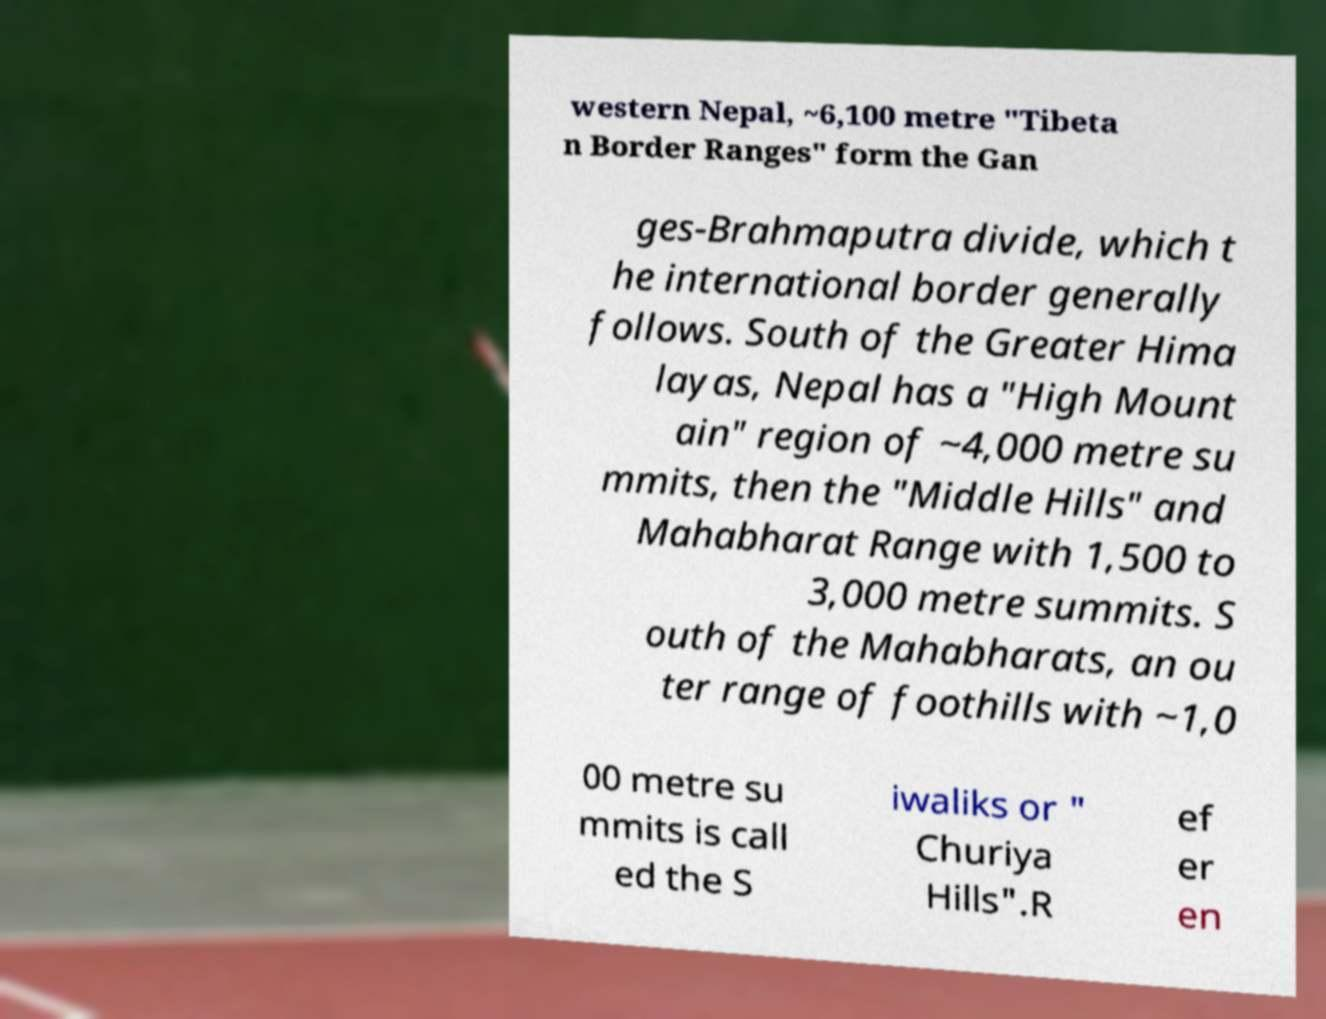Please read and relay the text visible in this image. What does it say? western Nepal, ~6,100 metre "Tibeta n Border Ranges" form the Gan ges-Brahmaputra divide, which t he international border generally follows. South of the Greater Hima layas, Nepal has a "High Mount ain" region of ~4,000 metre su mmits, then the "Middle Hills" and Mahabharat Range with 1,500 to 3,000 metre summits. S outh of the Mahabharats, an ou ter range of foothills with ~1,0 00 metre su mmits is call ed the S iwaliks or " Churiya Hills".R ef er en 